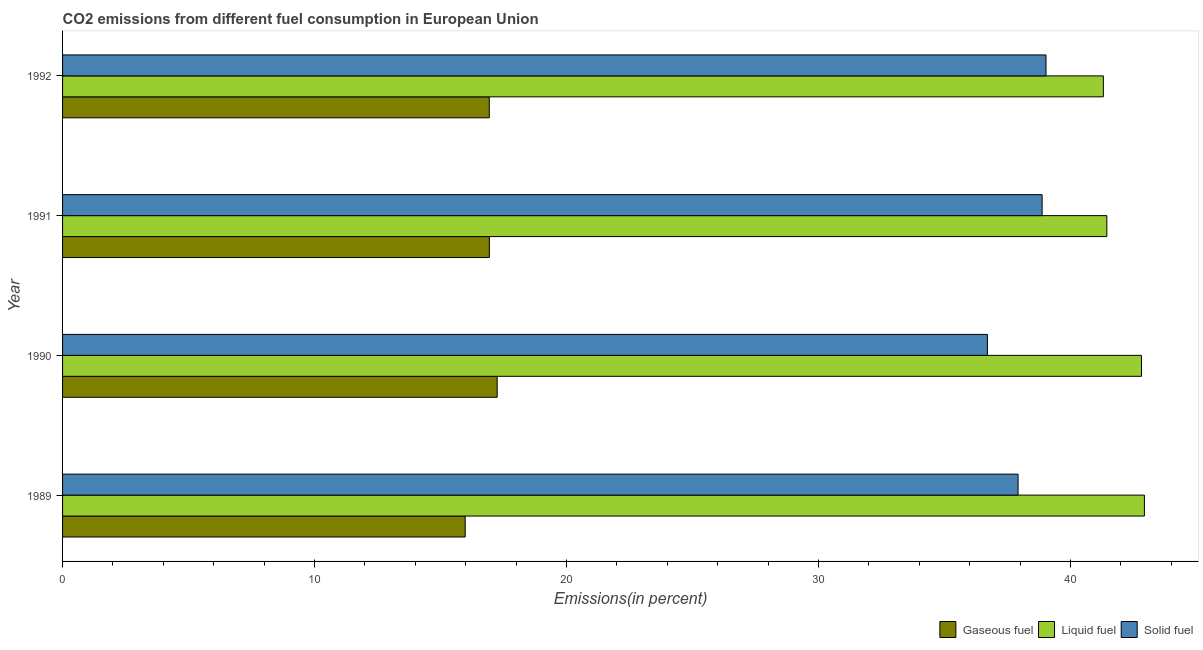How many different coloured bars are there?
Your response must be concise. 3. How many groups of bars are there?
Offer a very short reply. 4. How many bars are there on the 4th tick from the top?
Your answer should be very brief. 3. What is the label of the 2nd group of bars from the top?
Keep it short and to the point. 1991. In how many cases, is the number of bars for a given year not equal to the number of legend labels?
Give a very brief answer. 0. What is the percentage of liquid fuel emission in 1992?
Give a very brief answer. 41.31. Across all years, what is the maximum percentage of gaseous fuel emission?
Your response must be concise. 17.25. Across all years, what is the minimum percentage of gaseous fuel emission?
Your answer should be compact. 15.98. In which year was the percentage of gaseous fuel emission minimum?
Your answer should be very brief. 1989. What is the total percentage of liquid fuel emission in the graph?
Give a very brief answer. 168.5. What is the difference between the percentage of solid fuel emission in 1991 and that in 1992?
Give a very brief answer. -0.15. What is the difference between the percentage of liquid fuel emission in 1992 and the percentage of solid fuel emission in 1991?
Make the answer very short. 2.43. What is the average percentage of gaseous fuel emission per year?
Your answer should be compact. 16.77. In the year 1989, what is the difference between the percentage of gaseous fuel emission and percentage of liquid fuel emission?
Offer a very short reply. -26.95. Is the percentage of solid fuel emission in 1989 less than that in 1990?
Your response must be concise. No. What is the difference between the highest and the second highest percentage of gaseous fuel emission?
Keep it short and to the point. 0.31. What is the difference between the highest and the lowest percentage of liquid fuel emission?
Your answer should be compact. 1.63. What does the 1st bar from the top in 1992 represents?
Keep it short and to the point. Solid fuel. What does the 2nd bar from the bottom in 1992 represents?
Make the answer very short. Liquid fuel. How many bars are there?
Make the answer very short. 12. What is the difference between two consecutive major ticks on the X-axis?
Your answer should be very brief. 10. Are the values on the major ticks of X-axis written in scientific E-notation?
Offer a terse response. No. Does the graph contain any zero values?
Your response must be concise. No. Does the graph contain grids?
Your answer should be very brief. No. Where does the legend appear in the graph?
Provide a succinct answer. Bottom right. What is the title of the graph?
Make the answer very short. CO2 emissions from different fuel consumption in European Union. Does "Primary" appear as one of the legend labels in the graph?
Give a very brief answer. No. What is the label or title of the X-axis?
Your response must be concise. Emissions(in percent). What is the label or title of the Y-axis?
Provide a succinct answer. Year. What is the Emissions(in percent) in Gaseous fuel in 1989?
Offer a terse response. 15.98. What is the Emissions(in percent) in Liquid fuel in 1989?
Your response must be concise. 42.93. What is the Emissions(in percent) of Solid fuel in 1989?
Make the answer very short. 37.92. What is the Emissions(in percent) of Gaseous fuel in 1990?
Your answer should be very brief. 17.25. What is the Emissions(in percent) in Liquid fuel in 1990?
Offer a very short reply. 42.82. What is the Emissions(in percent) of Solid fuel in 1990?
Offer a very short reply. 36.7. What is the Emissions(in percent) of Gaseous fuel in 1991?
Provide a succinct answer. 16.94. What is the Emissions(in percent) in Liquid fuel in 1991?
Your answer should be very brief. 41.44. What is the Emissions(in percent) of Solid fuel in 1991?
Give a very brief answer. 38.87. What is the Emissions(in percent) in Gaseous fuel in 1992?
Your answer should be compact. 16.93. What is the Emissions(in percent) in Liquid fuel in 1992?
Provide a short and direct response. 41.31. What is the Emissions(in percent) in Solid fuel in 1992?
Offer a very short reply. 39.03. Across all years, what is the maximum Emissions(in percent) of Gaseous fuel?
Ensure brevity in your answer.  17.25. Across all years, what is the maximum Emissions(in percent) in Liquid fuel?
Make the answer very short. 42.93. Across all years, what is the maximum Emissions(in percent) of Solid fuel?
Offer a very short reply. 39.03. Across all years, what is the minimum Emissions(in percent) of Gaseous fuel?
Ensure brevity in your answer.  15.98. Across all years, what is the minimum Emissions(in percent) in Liquid fuel?
Offer a terse response. 41.31. Across all years, what is the minimum Emissions(in percent) in Solid fuel?
Your response must be concise. 36.7. What is the total Emissions(in percent) in Gaseous fuel in the graph?
Your response must be concise. 67.1. What is the total Emissions(in percent) of Liquid fuel in the graph?
Your answer should be compact. 168.5. What is the total Emissions(in percent) of Solid fuel in the graph?
Provide a succinct answer. 152.53. What is the difference between the Emissions(in percent) in Gaseous fuel in 1989 and that in 1990?
Provide a short and direct response. -1.27. What is the difference between the Emissions(in percent) of Liquid fuel in 1989 and that in 1990?
Provide a short and direct response. 0.12. What is the difference between the Emissions(in percent) of Solid fuel in 1989 and that in 1990?
Make the answer very short. 1.22. What is the difference between the Emissions(in percent) of Gaseous fuel in 1989 and that in 1991?
Offer a very short reply. -0.96. What is the difference between the Emissions(in percent) in Liquid fuel in 1989 and that in 1991?
Ensure brevity in your answer.  1.49. What is the difference between the Emissions(in percent) in Solid fuel in 1989 and that in 1991?
Offer a terse response. -0.95. What is the difference between the Emissions(in percent) in Gaseous fuel in 1989 and that in 1992?
Your answer should be very brief. -0.96. What is the difference between the Emissions(in percent) of Liquid fuel in 1989 and that in 1992?
Make the answer very short. 1.63. What is the difference between the Emissions(in percent) of Solid fuel in 1989 and that in 1992?
Ensure brevity in your answer.  -1.11. What is the difference between the Emissions(in percent) in Gaseous fuel in 1990 and that in 1991?
Ensure brevity in your answer.  0.31. What is the difference between the Emissions(in percent) in Liquid fuel in 1990 and that in 1991?
Make the answer very short. 1.37. What is the difference between the Emissions(in percent) of Solid fuel in 1990 and that in 1991?
Give a very brief answer. -2.17. What is the difference between the Emissions(in percent) of Gaseous fuel in 1990 and that in 1992?
Keep it short and to the point. 0.31. What is the difference between the Emissions(in percent) of Liquid fuel in 1990 and that in 1992?
Your response must be concise. 1.51. What is the difference between the Emissions(in percent) in Solid fuel in 1990 and that in 1992?
Your response must be concise. -2.32. What is the difference between the Emissions(in percent) in Gaseous fuel in 1991 and that in 1992?
Ensure brevity in your answer.  0. What is the difference between the Emissions(in percent) in Liquid fuel in 1991 and that in 1992?
Your response must be concise. 0.14. What is the difference between the Emissions(in percent) in Solid fuel in 1991 and that in 1992?
Your answer should be very brief. -0.15. What is the difference between the Emissions(in percent) of Gaseous fuel in 1989 and the Emissions(in percent) of Liquid fuel in 1990?
Give a very brief answer. -26.84. What is the difference between the Emissions(in percent) in Gaseous fuel in 1989 and the Emissions(in percent) in Solid fuel in 1990?
Your answer should be compact. -20.73. What is the difference between the Emissions(in percent) in Liquid fuel in 1989 and the Emissions(in percent) in Solid fuel in 1990?
Offer a terse response. 6.23. What is the difference between the Emissions(in percent) in Gaseous fuel in 1989 and the Emissions(in percent) in Liquid fuel in 1991?
Provide a short and direct response. -25.46. What is the difference between the Emissions(in percent) of Gaseous fuel in 1989 and the Emissions(in percent) of Solid fuel in 1991?
Give a very brief answer. -22.9. What is the difference between the Emissions(in percent) in Liquid fuel in 1989 and the Emissions(in percent) in Solid fuel in 1991?
Give a very brief answer. 4.06. What is the difference between the Emissions(in percent) in Gaseous fuel in 1989 and the Emissions(in percent) in Liquid fuel in 1992?
Your response must be concise. -25.33. What is the difference between the Emissions(in percent) in Gaseous fuel in 1989 and the Emissions(in percent) in Solid fuel in 1992?
Your answer should be very brief. -23.05. What is the difference between the Emissions(in percent) of Liquid fuel in 1989 and the Emissions(in percent) of Solid fuel in 1992?
Offer a terse response. 3.91. What is the difference between the Emissions(in percent) in Gaseous fuel in 1990 and the Emissions(in percent) in Liquid fuel in 1991?
Keep it short and to the point. -24.2. What is the difference between the Emissions(in percent) in Gaseous fuel in 1990 and the Emissions(in percent) in Solid fuel in 1991?
Make the answer very short. -21.63. What is the difference between the Emissions(in percent) of Liquid fuel in 1990 and the Emissions(in percent) of Solid fuel in 1991?
Offer a terse response. 3.94. What is the difference between the Emissions(in percent) in Gaseous fuel in 1990 and the Emissions(in percent) in Liquid fuel in 1992?
Provide a short and direct response. -24.06. What is the difference between the Emissions(in percent) of Gaseous fuel in 1990 and the Emissions(in percent) of Solid fuel in 1992?
Ensure brevity in your answer.  -21.78. What is the difference between the Emissions(in percent) in Liquid fuel in 1990 and the Emissions(in percent) in Solid fuel in 1992?
Your answer should be compact. 3.79. What is the difference between the Emissions(in percent) of Gaseous fuel in 1991 and the Emissions(in percent) of Liquid fuel in 1992?
Your answer should be very brief. -24.37. What is the difference between the Emissions(in percent) in Gaseous fuel in 1991 and the Emissions(in percent) in Solid fuel in 1992?
Your answer should be compact. -22.09. What is the difference between the Emissions(in percent) of Liquid fuel in 1991 and the Emissions(in percent) of Solid fuel in 1992?
Give a very brief answer. 2.41. What is the average Emissions(in percent) in Gaseous fuel per year?
Ensure brevity in your answer.  16.77. What is the average Emissions(in percent) in Liquid fuel per year?
Offer a very short reply. 42.13. What is the average Emissions(in percent) of Solid fuel per year?
Provide a succinct answer. 38.13. In the year 1989, what is the difference between the Emissions(in percent) of Gaseous fuel and Emissions(in percent) of Liquid fuel?
Your response must be concise. -26.95. In the year 1989, what is the difference between the Emissions(in percent) in Gaseous fuel and Emissions(in percent) in Solid fuel?
Your response must be concise. -21.94. In the year 1989, what is the difference between the Emissions(in percent) in Liquid fuel and Emissions(in percent) in Solid fuel?
Provide a succinct answer. 5.01. In the year 1990, what is the difference between the Emissions(in percent) of Gaseous fuel and Emissions(in percent) of Liquid fuel?
Keep it short and to the point. -25.57. In the year 1990, what is the difference between the Emissions(in percent) in Gaseous fuel and Emissions(in percent) in Solid fuel?
Provide a short and direct response. -19.46. In the year 1990, what is the difference between the Emissions(in percent) in Liquid fuel and Emissions(in percent) in Solid fuel?
Offer a terse response. 6.11. In the year 1991, what is the difference between the Emissions(in percent) in Gaseous fuel and Emissions(in percent) in Liquid fuel?
Your response must be concise. -24.51. In the year 1991, what is the difference between the Emissions(in percent) in Gaseous fuel and Emissions(in percent) in Solid fuel?
Offer a very short reply. -21.94. In the year 1991, what is the difference between the Emissions(in percent) in Liquid fuel and Emissions(in percent) in Solid fuel?
Keep it short and to the point. 2.57. In the year 1992, what is the difference between the Emissions(in percent) in Gaseous fuel and Emissions(in percent) in Liquid fuel?
Your answer should be very brief. -24.37. In the year 1992, what is the difference between the Emissions(in percent) in Gaseous fuel and Emissions(in percent) in Solid fuel?
Your answer should be compact. -22.09. In the year 1992, what is the difference between the Emissions(in percent) in Liquid fuel and Emissions(in percent) in Solid fuel?
Offer a very short reply. 2.28. What is the ratio of the Emissions(in percent) in Gaseous fuel in 1989 to that in 1990?
Provide a succinct answer. 0.93. What is the ratio of the Emissions(in percent) in Solid fuel in 1989 to that in 1990?
Your answer should be very brief. 1.03. What is the ratio of the Emissions(in percent) of Gaseous fuel in 1989 to that in 1991?
Your answer should be compact. 0.94. What is the ratio of the Emissions(in percent) in Liquid fuel in 1989 to that in 1991?
Your answer should be compact. 1.04. What is the ratio of the Emissions(in percent) of Solid fuel in 1989 to that in 1991?
Offer a very short reply. 0.98. What is the ratio of the Emissions(in percent) in Gaseous fuel in 1989 to that in 1992?
Your response must be concise. 0.94. What is the ratio of the Emissions(in percent) in Liquid fuel in 1989 to that in 1992?
Provide a succinct answer. 1.04. What is the ratio of the Emissions(in percent) of Solid fuel in 1989 to that in 1992?
Offer a very short reply. 0.97. What is the ratio of the Emissions(in percent) in Gaseous fuel in 1990 to that in 1991?
Your response must be concise. 1.02. What is the ratio of the Emissions(in percent) of Liquid fuel in 1990 to that in 1991?
Offer a very short reply. 1.03. What is the ratio of the Emissions(in percent) in Solid fuel in 1990 to that in 1991?
Provide a succinct answer. 0.94. What is the ratio of the Emissions(in percent) of Gaseous fuel in 1990 to that in 1992?
Offer a terse response. 1.02. What is the ratio of the Emissions(in percent) of Liquid fuel in 1990 to that in 1992?
Ensure brevity in your answer.  1.04. What is the ratio of the Emissions(in percent) in Solid fuel in 1990 to that in 1992?
Offer a terse response. 0.94. What is the ratio of the Emissions(in percent) in Gaseous fuel in 1991 to that in 1992?
Offer a very short reply. 1. What is the difference between the highest and the second highest Emissions(in percent) in Gaseous fuel?
Give a very brief answer. 0.31. What is the difference between the highest and the second highest Emissions(in percent) of Liquid fuel?
Your response must be concise. 0.12. What is the difference between the highest and the second highest Emissions(in percent) in Solid fuel?
Offer a very short reply. 0.15. What is the difference between the highest and the lowest Emissions(in percent) of Gaseous fuel?
Offer a terse response. 1.27. What is the difference between the highest and the lowest Emissions(in percent) in Liquid fuel?
Your answer should be compact. 1.63. What is the difference between the highest and the lowest Emissions(in percent) of Solid fuel?
Make the answer very short. 2.32. 